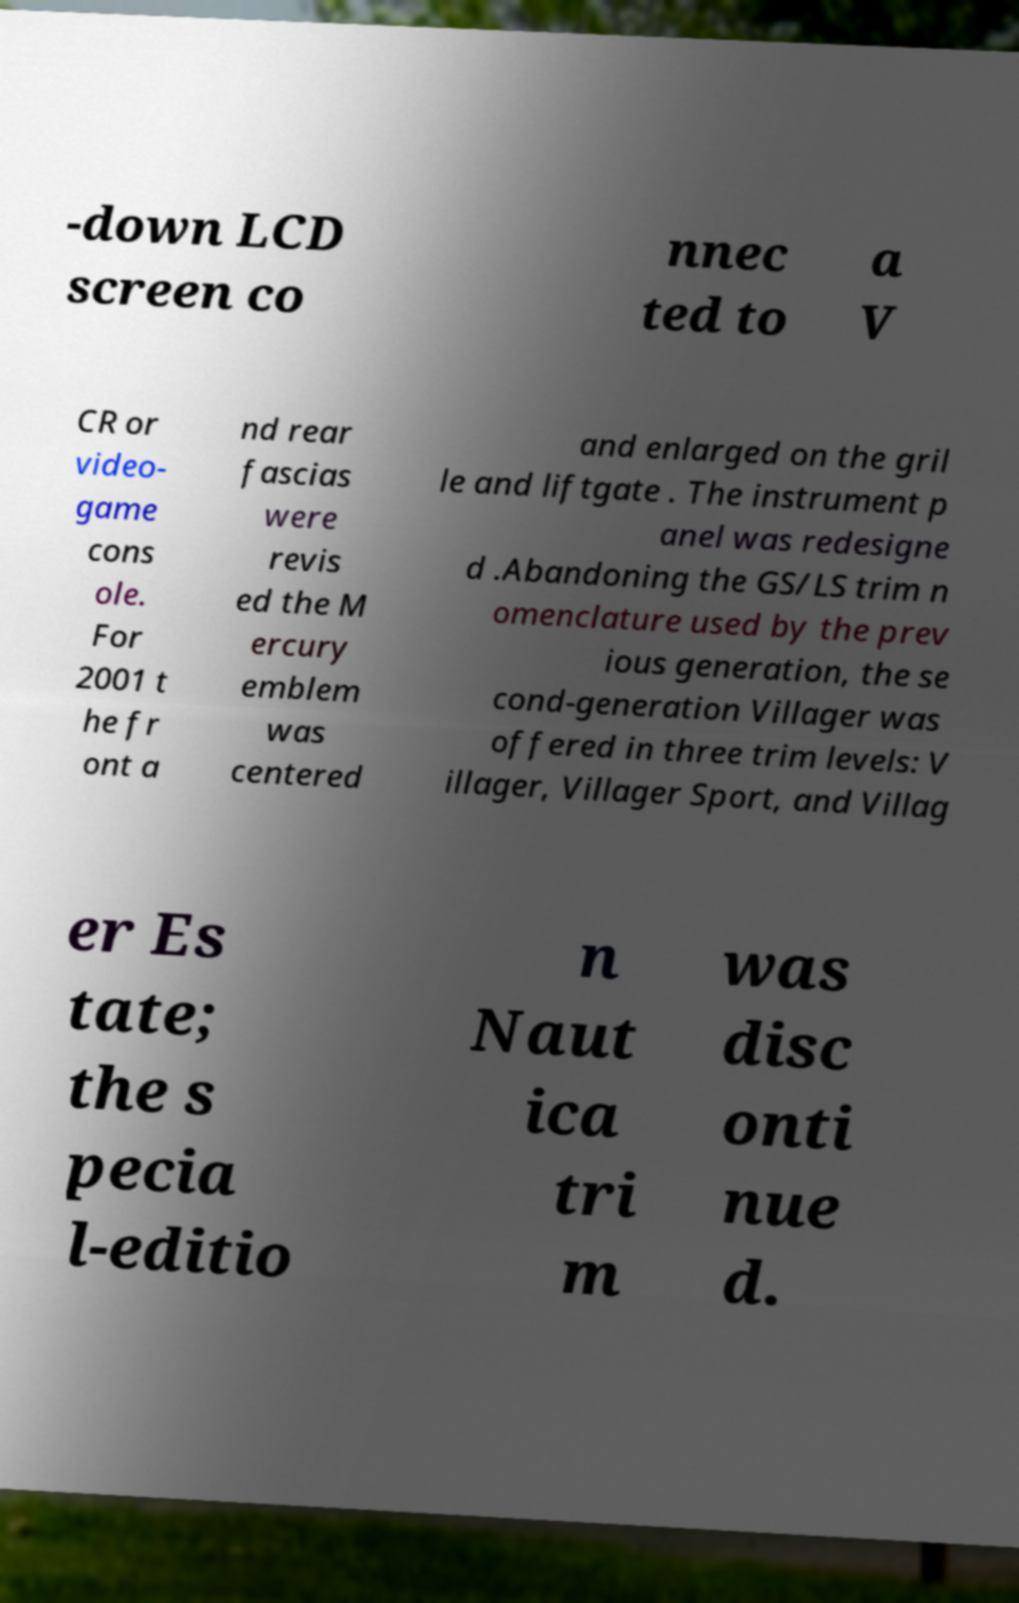Please read and relay the text visible in this image. What does it say? -down LCD screen co nnec ted to a V CR or video- game cons ole. For 2001 t he fr ont a nd rear fascias were revis ed the M ercury emblem was centered and enlarged on the gril le and liftgate . The instrument p anel was redesigne d .Abandoning the GS/LS trim n omenclature used by the prev ious generation, the se cond-generation Villager was offered in three trim levels: V illager, Villager Sport, and Villag er Es tate; the s pecia l-editio n Naut ica tri m was disc onti nue d. 